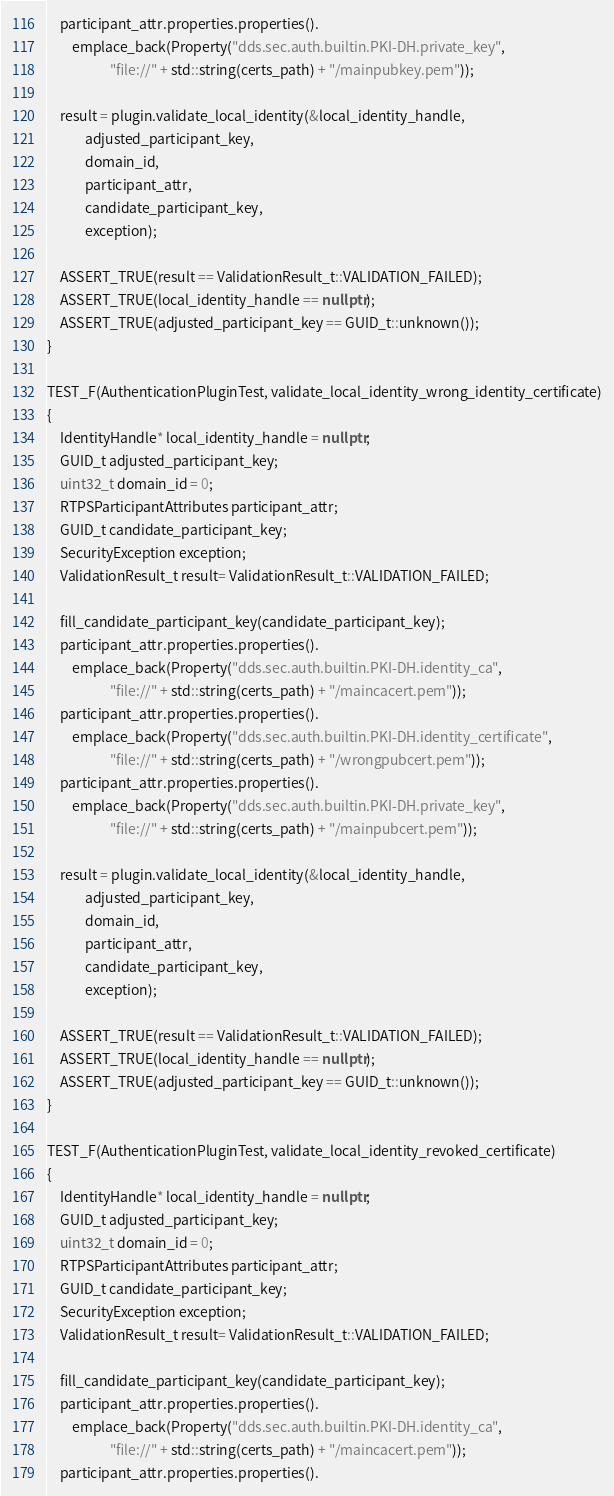<code> <loc_0><loc_0><loc_500><loc_500><_C++_>    participant_attr.properties.properties().
        emplace_back(Property("dds.sec.auth.builtin.PKI-DH.private_key",
                    "file://" + std::string(certs_path) + "/mainpubkey.pem"));

    result = plugin.validate_local_identity(&local_identity_handle,
            adjusted_participant_key,
            domain_id,
            participant_attr,
            candidate_participant_key,
            exception);

    ASSERT_TRUE(result == ValidationResult_t::VALIDATION_FAILED);
    ASSERT_TRUE(local_identity_handle == nullptr);
    ASSERT_TRUE(adjusted_participant_key == GUID_t::unknown());
}

TEST_F(AuthenticationPluginTest, validate_local_identity_wrong_identity_certificate)
{
    IdentityHandle* local_identity_handle = nullptr;
    GUID_t adjusted_participant_key;
    uint32_t domain_id = 0;
    RTPSParticipantAttributes participant_attr;
    GUID_t candidate_participant_key;
    SecurityException exception;
    ValidationResult_t result= ValidationResult_t::VALIDATION_FAILED;

    fill_candidate_participant_key(candidate_participant_key);
    participant_attr.properties.properties().
        emplace_back(Property("dds.sec.auth.builtin.PKI-DH.identity_ca",
                    "file://" + std::string(certs_path) + "/maincacert.pem"));
    participant_attr.properties.properties().
        emplace_back(Property("dds.sec.auth.builtin.PKI-DH.identity_certificate",
                    "file://" + std::string(certs_path) + "/wrongpubcert.pem"));
    participant_attr.properties.properties().
        emplace_back(Property("dds.sec.auth.builtin.PKI-DH.private_key",
                    "file://" + std::string(certs_path) + "/mainpubcert.pem"));

    result = plugin.validate_local_identity(&local_identity_handle,
            adjusted_participant_key,
            domain_id,
            participant_attr,
            candidate_participant_key,
            exception);

    ASSERT_TRUE(result == ValidationResult_t::VALIDATION_FAILED);
    ASSERT_TRUE(local_identity_handle == nullptr);
    ASSERT_TRUE(adjusted_participant_key == GUID_t::unknown());
}

TEST_F(AuthenticationPluginTest, validate_local_identity_revoked_certificate)
{
    IdentityHandle* local_identity_handle = nullptr;
    GUID_t adjusted_participant_key;
    uint32_t domain_id = 0;
    RTPSParticipantAttributes participant_attr;
    GUID_t candidate_participant_key;
    SecurityException exception;
    ValidationResult_t result= ValidationResult_t::VALIDATION_FAILED;

    fill_candidate_participant_key(candidate_participant_key);
    participant_attr.properties.properties().
        emplace_back(Property("dds.sec.auth.builtin.PKI-DH.identity_ca",
                    "file://" + std::string(certs_path) + "/maincacert.pem"));
    participant_attr.properties.properties().</code> 